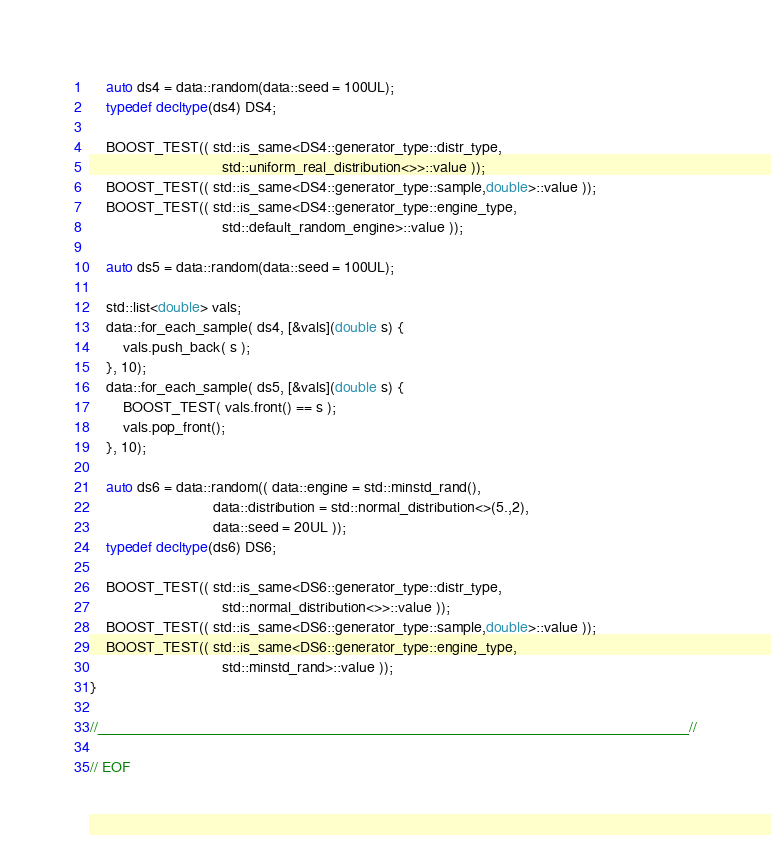<code> <loc_0><loc_0><loc_500><loc_500><_C++_>    auto ds4 = data::random(data::seed = 100UL);
    typedef decltype(ds4) DS4;

    BOOST_TEST(( std::is_same<DS4::generator_type::distr_type,
                                std::uniform_real_distribution<>>::value ));
    BOOST_TEST(( std::is_same<DS4::generator_type::sample,double>::value ));
    BOOST_TEST(( std::is_same<DS4::generator_type::engine_type,
                                std::default_random_engine>::value ));

    auto ds5 = data::random(data::seed = 100UL);

    std::list<double> vals;
    data::for_each_sample( ds4, [&vals](double s) {
        vals.push_back( s );
    }, 10);
    data::for_each_sample( ds5, [&vals](double s) {
        BOOST_TEST( vals.front() == s );
        vals.pop_front();
    }, 10);

    auto ds6 = data::random(( data::engine = std::minstd_rand(),
                              data::distribution = std::normal_distribution<>(5.,2),
                              data::seed = 20UL ));
    typedef decltype(ds6) DS6;

    BOOST_TEST(( std::is_same<DS6::generator_type::distr_type,
                                std::normal_distribution<>>::value ));
    BOOST_TEST(( std::is_same<DS6::generator_type::sample,double>::value ));
    BOOST_TEST(( std::is_same<DS6::generator_type::engine_type,
                                std::minstd_rand>::value ));
}

//____________________________________________________________________________//

// EOF

</code> 